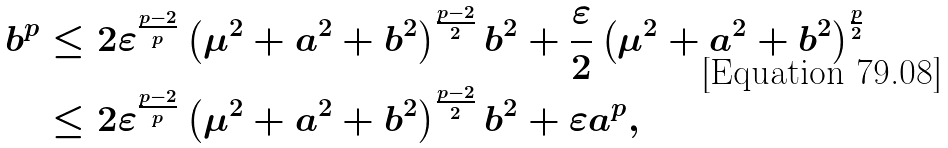Convert formula to latex. <formula><loc_0><loc_0><loc_500><loc_500>b ^ { p } & \leq 2 \varepsilon ^ { \frac { p - 2 } { p } } \left ( \mu ^ { 2 } + a ^ { 2 } + b ^ { 2 } \right ) ^ { \frac { p - 2 } { 2 } } b ^ { 2 } + \frac { \varepsilon } { 2 } \left ( \mu ^ { 2 } + a ^ { 2 } + b ^ { 2 } \right ) ^ { \frac { p } { 2 } } \\ & \leq 2 \varepsilon ^ { \frac { p - 2 } { p } } \left ( \mu ^ { 2 } + a ^ { 2 } + b ^ { 2 } \right ) ^ { \frac { p - 2 } { 2 } } b ^ { 2 } + \varepsilon a ^ { p } ,</formula> 